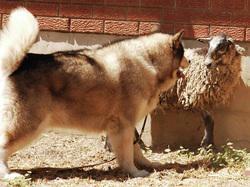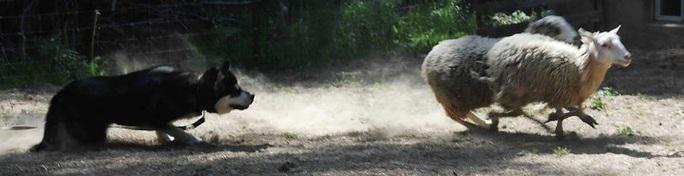The first image is the image on the left, the second image is the image on the right. For the images displayed, is the sentence "There are dogs with sheep in each image" factually correct? Answer yes or no. Yes. The first image is the image on the left, the second image is the image on the right. Given the left and right images, does the statement "there are at least 6 husky dogs on a grassy hill" hold true? Answer yes or no. No. 